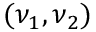Convert formula to latex. <formula><loc_0><loc_0><loc_500><loc_500>( \nu _ { 1 } , \nu _ { 2 } )</formula> 